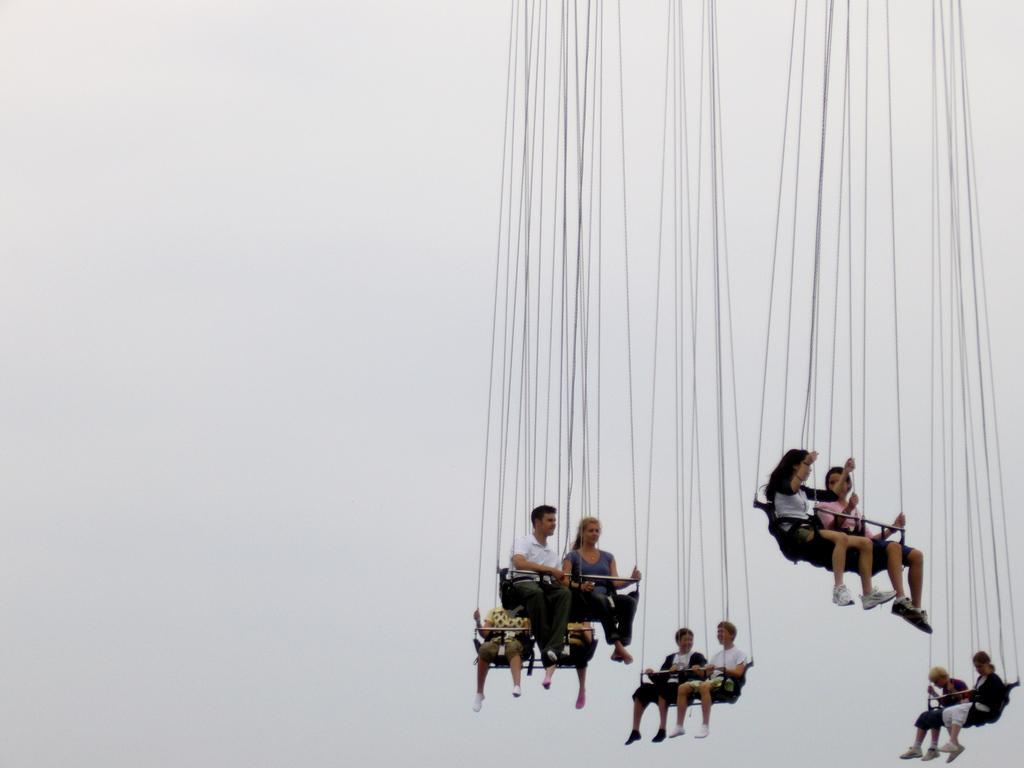Can you describe this image briefly? In this picture I can see some people are sitting on benches. This benches are attached with wires. In the background I can see the sky. 